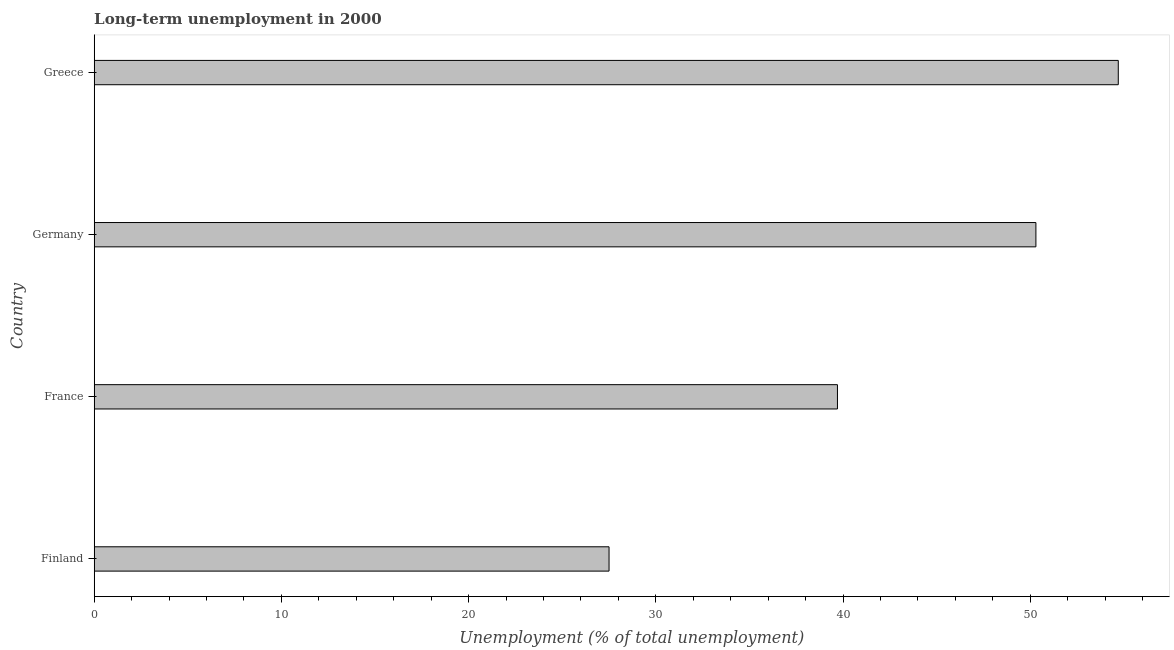Does the graph contain any zero values?
Offer a terse response. No. Does the graph contain grids?
Keep it short and to the point. No. What is the title of the graph?
Keep it short and to the point. Long-term unemployment in 2000. What is the label or title of the X-axis?
Offer a very short reply. Unemployment (% of total unemployment). What is the long-term unemployment in France?
Offer a very short reply. 39.7. Across all countries, what is the maximum long-term unemployment?
Provide a short and direct response. 54.7. Across all countries, what is the minimum long-term unemployment?
Your answer should be very brief. 27.5. In which country was the long-term unemployment maximum?
Give a very brief answer. Greece. In which country was the long-term unemployment minimum?
Provide a short and direct response. Finland. What is the sum of the long-term unemployment?
Make the answer very short. 172.2. What is the difference between the long-term unemployment in Finland and France?
Provide a short and direct response. -12.2. What is the average long-term unemployment per country?
Your answer should be very brief. 43.05. In how many countries, is the long-term unemployment greater than 44 %?
Ensure brevity in your answer.  2. What is the ratio of the long-term unemployment in Finland to that in France?
Your answer should be very brief. 0.69. Is the long-term unemployment in Germany less than that in Greece?
Offer a very short reply. Yes. Is the sum of the long-term unemployment in France and Germany greater than the maximum long-term unemployment across all countries?
Provide a succinct answer. Yes. What is the difference between the highest and the lowest long-term unemployment?
Provide a succinct answer. 27.2. How many bars are there?
Offer a terse response. 4. How many countries are there in the graph?
Your answer should be very brief. 4. What is the difference between two consecutive major ticks on the X-axis?
Give a very brief answer. 10. Are the values on the major ticks of X-axis written in scientific E-notation?
Ensure brevity in your answer.  No. What is the Unemployment (% of total unemployment) in France?
Ensure brevity in your answer.  39.7. What is the Unemployment (% of total unemployment) of Germany?
Your response must be concise. 50.3. What is the Unemployment (% of total unemployment) in Greece?
Provide a short and direct response. 54.7. What is the difference between the Unemployment (% of total unemployment) in Finland and France?
Ensure brevity in your answer.  -12.2. What is the difference between the Unemployment (% of total unemployment) in Finland and Germany?
Your response must be concise. -22.8. What is the difference between the Unemployment (% of total unemployment) in Finland and Greece?
Provide a succinct answer. -27.2. What is the difference between the Unemployment (% of total unemployment) in France and Greece?
Keep it short and to the point. -15. What is the difference between the Unemployment (% of total unemployment) in Germany and Greece?
Offer a very short reply. -4.4. What is the ratio of the Unemployment (% of total unemployment) in Finland to that in France?
Offer a terse response. 0.69. What is the ratio of the Unemployment (% of total unemployment) in Finland to that in Germany?
Your answer should be very brief. 0.55. What is the ratio of the Unemployment (% of total unemployment) in Finland to that in Greece?
Give a very brief answer. 0.5. What is the ratio of the Unemployment (% of total unemployment) in France to that in Germany?
Offer a terse response. 0.79. What is the ratio of the Unemployment (% of total unemployment) in France to that in Greece?
Give a very brief answer. 0.73. What is the ratio of the Unemployment (% of total unemployment) in Germany to that in Greece?
Give a very brief answer. 0.92. 